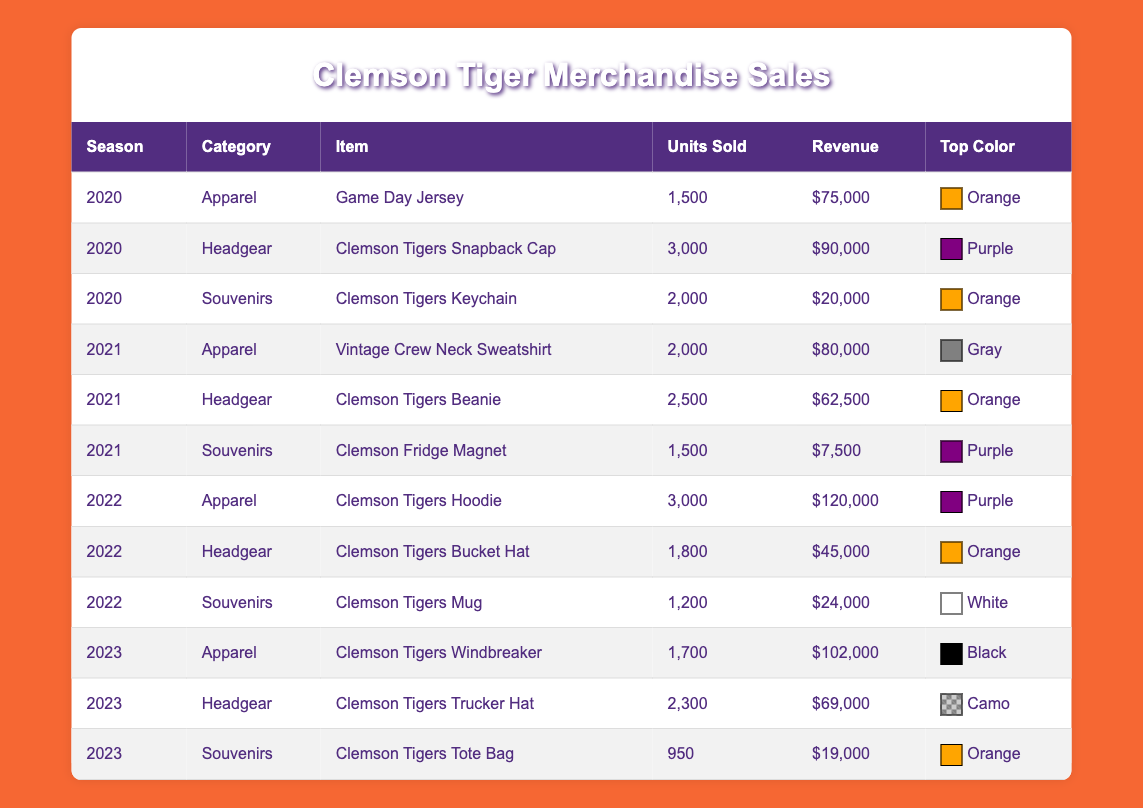What was the best-selling item in the 2021 season? The best-selling item is the Vintage Crew Neck Sweatshirt, which sold 2000 units with a revenue of $80,000. This information is directly obtained from the table under the 2021 season and apparel category.
Answer: Vintage Crew Neck Sweatshirt How many units of Clemson Tigers Hoodies were sold in 2022? The table states that 3,000 units of Clemson Tigers Hoodies were sold in 2022, making it the highest-selling item in that year.
Answer: 3000 What was the total revenue from all merchandise sales in the 2020 season? To calculate the total revenue from the 2020 season, we add the revenues of all items: $75,000 (Game Day Jersey) + $90,000 (Snapback Cap) + $20,000 (Keychain) = $185,000. Therefore, the total revenue for that season is $185,000.
Answer: $185,000 Was there a decrease in units sold for souvenirs from 2021 to 2022? In 2021, 1,500 units of the Clemson Fridge Magnet were sold, while in 2022, only 1,200 units of the Clemson Tigers Mug were sold. This indicates a decrease, so the answer is yes.
Answer: Yes What is the average revenue generated from apparel sales over the three seasons? To find the average, we first sum the revenues from apparel sales across all three seasons: $75,000 (2020) + $80,000 (2021) + $120,000 (2022) + $102,000 (2023) = $377,000. Then, divide by the number of seasons (4), giving an average of $94,250.
Answer: $94,250 Which season had the highest sales revenue from headgear? The sales revenue for headgear in each season is as follows: $90,000 in 2020, $62,500 in 2021, $45,000 in 2022, and $69,000 in 2023. The highest amount is from the 2020 season.
Answer: 2020 What percentage of total units sold in 2022 came from apparel items? In 2022, the total units sold were 3,000 (Hoodie) + 1,800 (Bucket Hat) + 1,200 (Mug) = 6,000. The units sold from apparel alone were 3,000. To get the percentage, (3,000/6,000) * 100 = 50%.
Answer: 50% Did Clemson Tigers Snapback Cap have the highest revenue among headgear items across all seasons? The Snapback Cap generated $90,000, which is higher than any other headgear item: $62,500 (Beanie), $45,000 (Bucket Hat), and $69,000 (Trucker Hat). So, the answer is yes.
Answer: Yes 